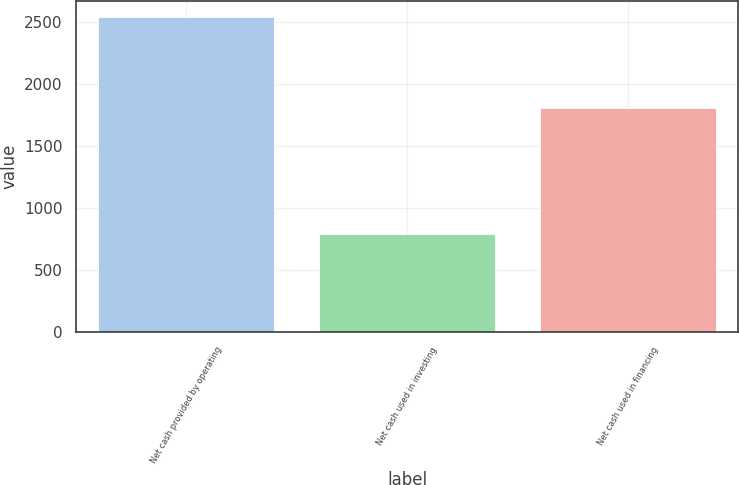Convert chart to OTSL. <chart><loc_0><loc_0><loc_500><loc_500><bar_chart><fcel>Net cash provided by operating<fcel>Net cash used in investing<fcel>Net cash used in financing<nl><fcel>2540<fcel>788<fcel>1803<nl></chart> 